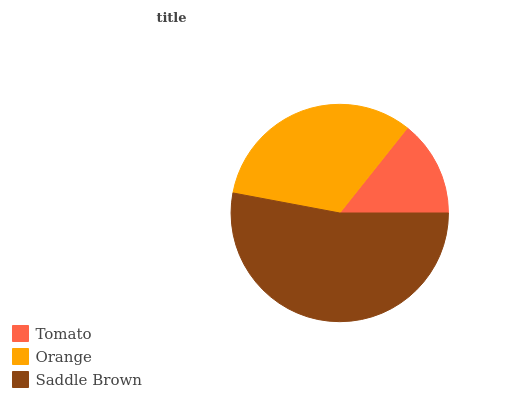Is Tomato the minimum?
Answer yes or no. Yes. Is Saddle Brown the maximum?
Answer yes or no. Yes. Is Orange the minimum?
Answer yes or no. No. Is Orange the maximum?
Answer yes or no. No. Is Orange greater than Tomato?
Answer yes or no. Yes. Is Tomato less than Orange?
Answer yes or no. Yes. Is Tomato greater than Orange?
Answer yes or no. No. Is Orange less than Tomato?
Answer yes or no. No. Is Orange the high median?
Answer yes or no. Yes. Is Orange the low median?
Answer yes or no. Yes. Is Saddle Brown the high median?
Answer yes or no. No. Is Saddle Brown the low median?
Answer yes or no. No. 